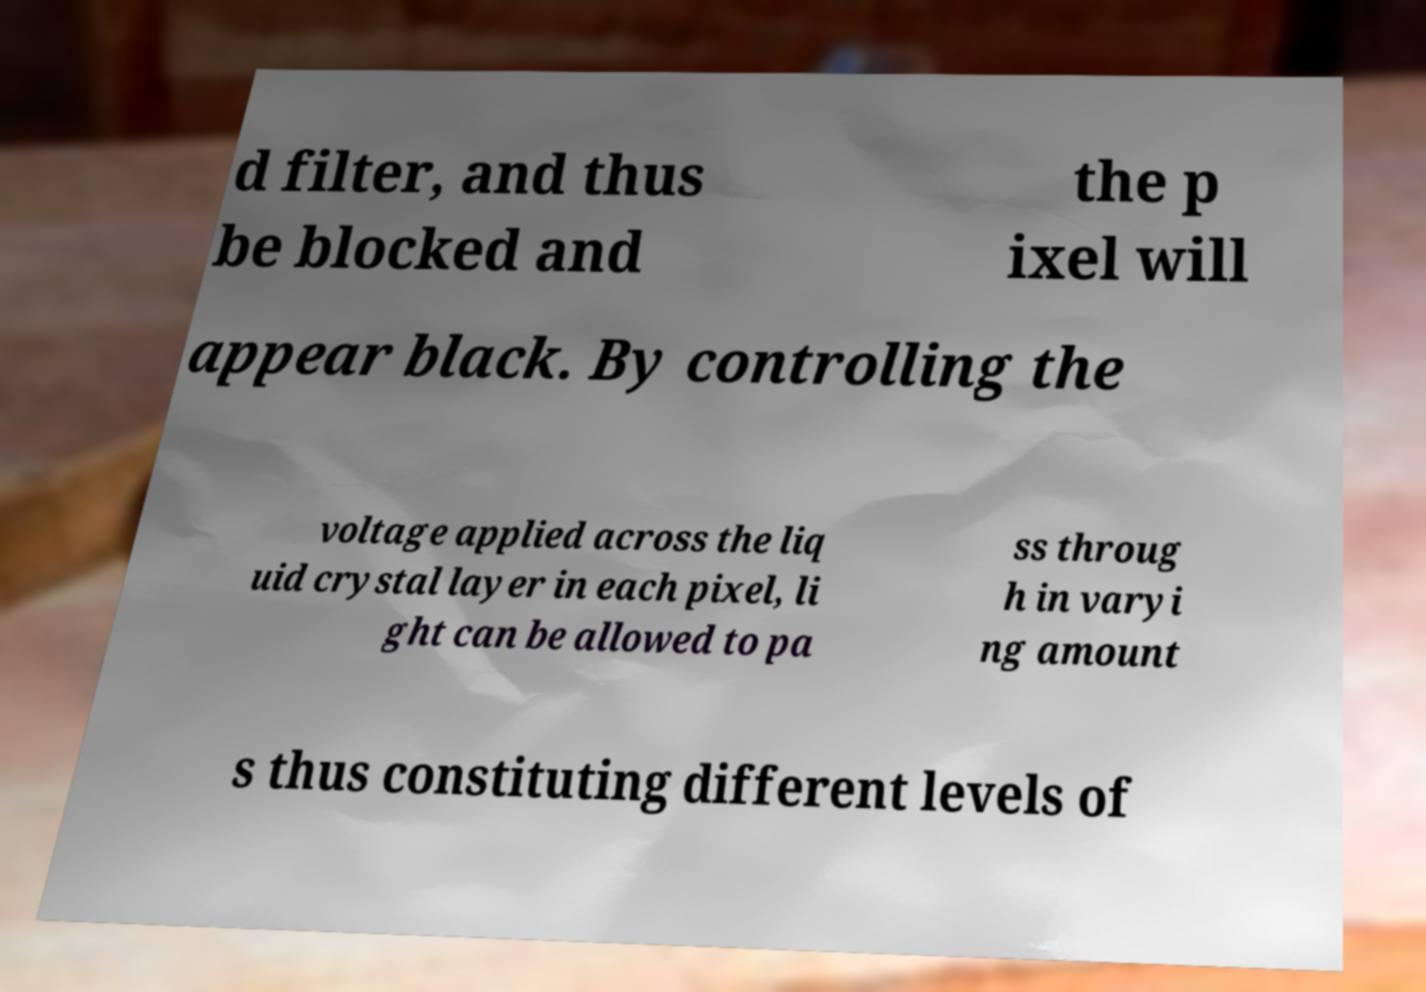Can you read and provide the text displayed in the image?This photo seems to have some interesting text. Can you extract and type it out for me? d filter, and thus be blocked and the p ixel will appear black. By controlling the voltage applied across the liq uid crystal layer in each pixel, li ght can be allowed to pa ss throug h in varyi ng amount s thus constituting different levels of 